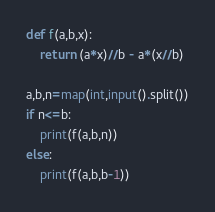<code> <loc_0><loc_0><loc_500><loc_500><_Python_>def f(a,b,x):
	return (a*x)//b - a*(x//b)
	
a,b,n=map(int,input().split())
if n<=b:
	print(f(a,b,n))
else:
	print(f(a,b,b-1))</code> 